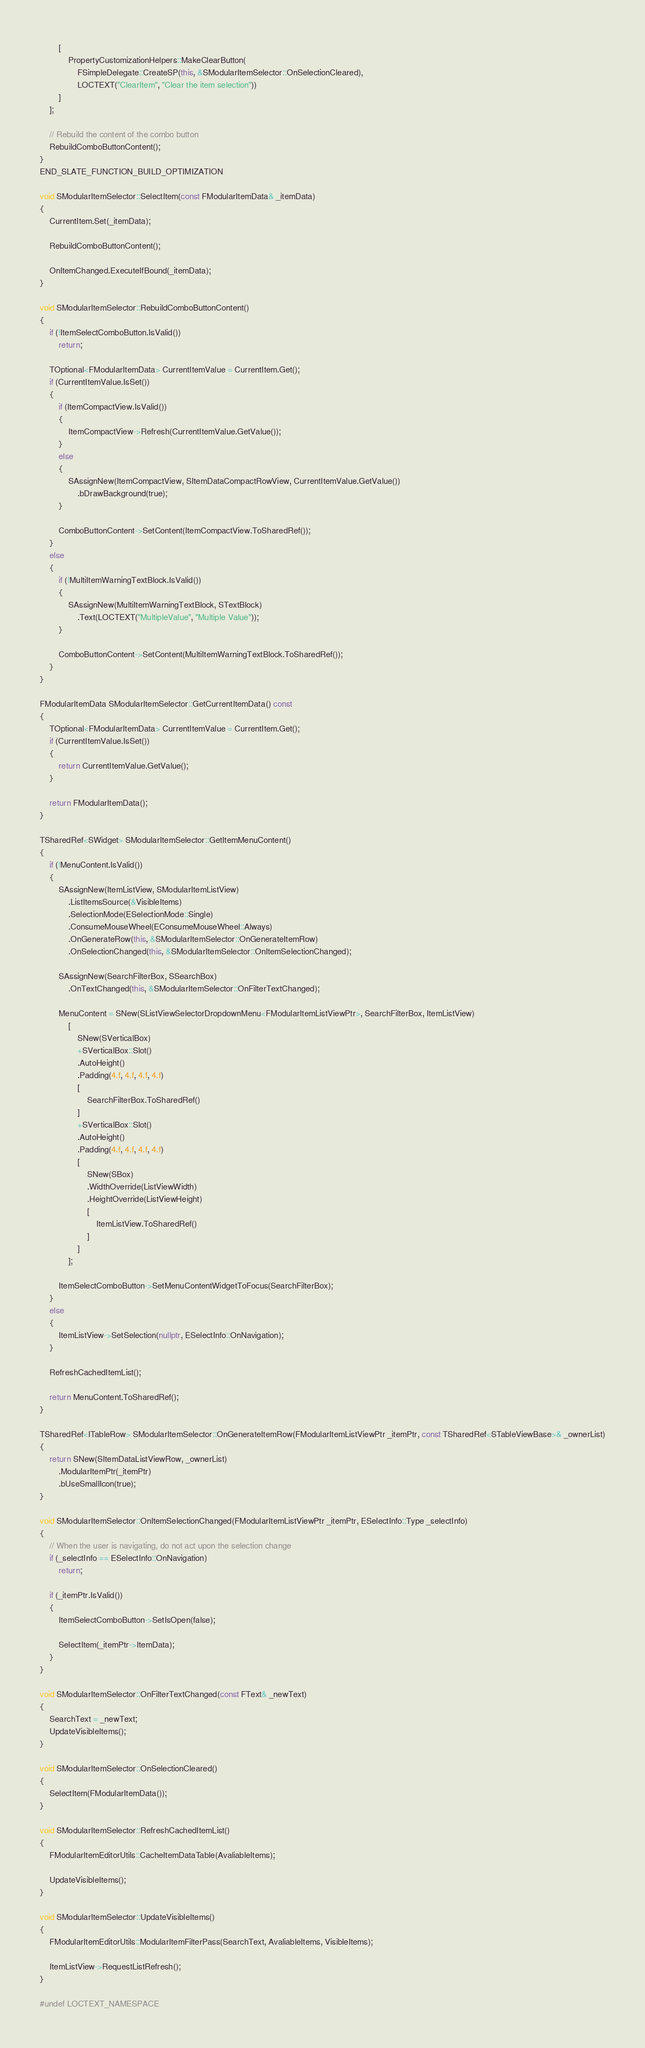<code> <loc_0><loc_0><loc_500><loc_500><_C++_>		[
			PropertyCustomizationHelpers::MakeClearButton(
				FSimpleDelegate::CreateSP(this, &SModularItemSelector::OnSelectionCleared),
				LOCTEXT("ClearItem", "Clear the item selection"))
		]
	];

	// Rebuild the content of the combo button
	RebuildComboButtonContent();
}
END_SLATE_FUNCTION_BUILD_OPTIMIZATION

void SModularItemSelector::SelectItem(const FModularItemData& _itemData)
{
	CurrentItem.Set(_itemData);

	RebuildComboButtonContent();
	
	OnItemChanged.ExecuteIfBound(_itemData);
}

void SModularItemSelector::RebuildComboButtonContent()
{
	if (!ItemSelectComboButton.IsValid())
		return;

	TOptional<FModularItemData> CurrentItemValue = CurrentItem.Get();
	if (CurrentItemValue.IsSet())
	{
		if (ItemCompactView.IsValid())
		{
			ItemCompactView->Refresh(CurrentItemValue.GetValue());
		}
		else
		{
			SAssignNew(ItemCompactView, SItemDataCompactRowView, CurrentItemValue.GetValue())
				.bDrawBackground(true);
		}

		ComboButtonContent->SetContent(ItemCompactView.ToSharedRef());
	}
	else
	{
		if (!MultiItemWarningTextBlock.IsValid())
		{
			SAssignNew(MultiItemWarningTextBlock, STextBlock)
				.Text(LOCTEXT("MultipleValue", "Multiple Value"));
		}

		ComboButtonContent->SetContent(MultiItemWarningTextBlock.ToSharedRef());
	}
}

FModularItemData SModularItemSelector::GetCurrentItemData() const
{
	TOptional<FModularItemData> CurrentItemValue = CurrentItem.Get();
	if (CurrentItemValue.IsSet())
	{
		return CurrentItemValue.GetValue();
	}

	return FModularItemData();
}

TSharedRef<SWidget> SModularItemSelector::GetItemMenuContent()
{
	if (!MenuContent.IsValid())
	{
		SAssignNew(ItemListView, SModularItemListView)
			.ListItemsSource(&VisibleItems)
			.SelectionMode(ESelectionMode::Single)
			.ConsumeMouseWheel(EConsumeMouseWheel::Always)
			.OnGenerateRow(this, &SModularItemSelector::OnGenerateItemRow)
			.OnSelectionChanged(this, &SModularItemSelector::OnItemSelectionChanged);

		SAssignNew(SearchFilterBox, SSearchBox)
			.OnTextChanged(this, &SModularItemSelector::OnFilterTextChanged);

		MenuContent = SNew(SListViewSelectorDropdownMenu<FModularItemListViewPtr>, SearchFilterBox, ItemListView)
			[
				SNew(SVerticalBox)
				+SVerticalBox::Slot()
				.AutoHeight()
				.Padding(4.f, 4.f, 4.f, 4.f)
				[
					SearchFilterBox.ToSharedRef()
				]
				+SVerticalBox::Slot()
				.AutoHeight()
				.Padding(4.f, 4.f, 4.f, 4.f)
				[
					SNew(SBox) 
					.WidthOverride(ListViewWidth)
					.HeightOverride(ListViewHeight)
					[
						ItemListView.ToSharedRef()
					]
				]
			];

		ItemSelectComboButton->SetMenuContentWidgetToFocus(SearchFilterBox);
	}
	else
	{
		ItemListView->SetSelection(nullptr, ESelectInfo::OnNavigation);
	}
	
	RefreshCachedItemList();

	return MenuContent.ToSharedRef();
}

TSharedRef<ITableRow> SModularItemSelector::OnGenerateItemRow(FModularItemListViewPtr _itemPtr, const TSharedRef<STableViewBase>& _ownerList)
{
	return SNew(SItemDataListViewRow, _ownerList)
		.ModularItemPtr(_itemPtr)
		.bUseSmallIcon(true);
}

void SModularItemSelector::OnItemSelectionChanged(FModularItemListViewPtr _itemPtr, ESelectInfo::Type _selectInfo)
{
	// When the user is navigating, do not act upon the selection change
	if (_selectInfo == ESelectInfo::OnNavigation)
		return;

	if (_itemPtr.IsValid())
	{
		ItemSelectComboButton->SetIsOpen(false);

		SelectItem(_itemPtr->ItemData);
	}
}

void SModularItemSelector::OnFilterTextChanged(const FText& _newText)
{
	SearchText = _newText;
	UpdateVisibleItems();
}

void SModularItemSelector::OnSelectionCleared()
{
	SelectItem(FModularItemData());
}

void SModularItemSelector::RefreshCachedItemList()
{
	FModularItemEditorUtils::CacheItemDataTable(AvaliableItems);

	UpdateVisibleItems();
}

void SModularItemSelector::UpdateVisibleItems()
{
	FModularItemEditorUtils::ModularItemFilterPass(SearchText, AvaliableItems, VisibleItems);

	ItemListView->RequestListRefresh();
}

#undef LOCTEXT_NAMESPACE</code> 